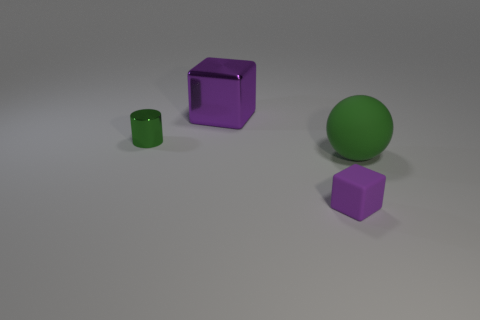Add 3 metallic things. How many objects exist? 7 Subtract all cylinders. How many objects are left? 3 Subtract all big cyan shiny cylinders. Subtract all rubber balls. How many objects are left? 3 Add 3 large green rubber objects. How many large green rubber objects are left? 4 Add 2 large green things. How many large green things exist? 3 Subtract 1 green spheres. How many objects are left? 3 